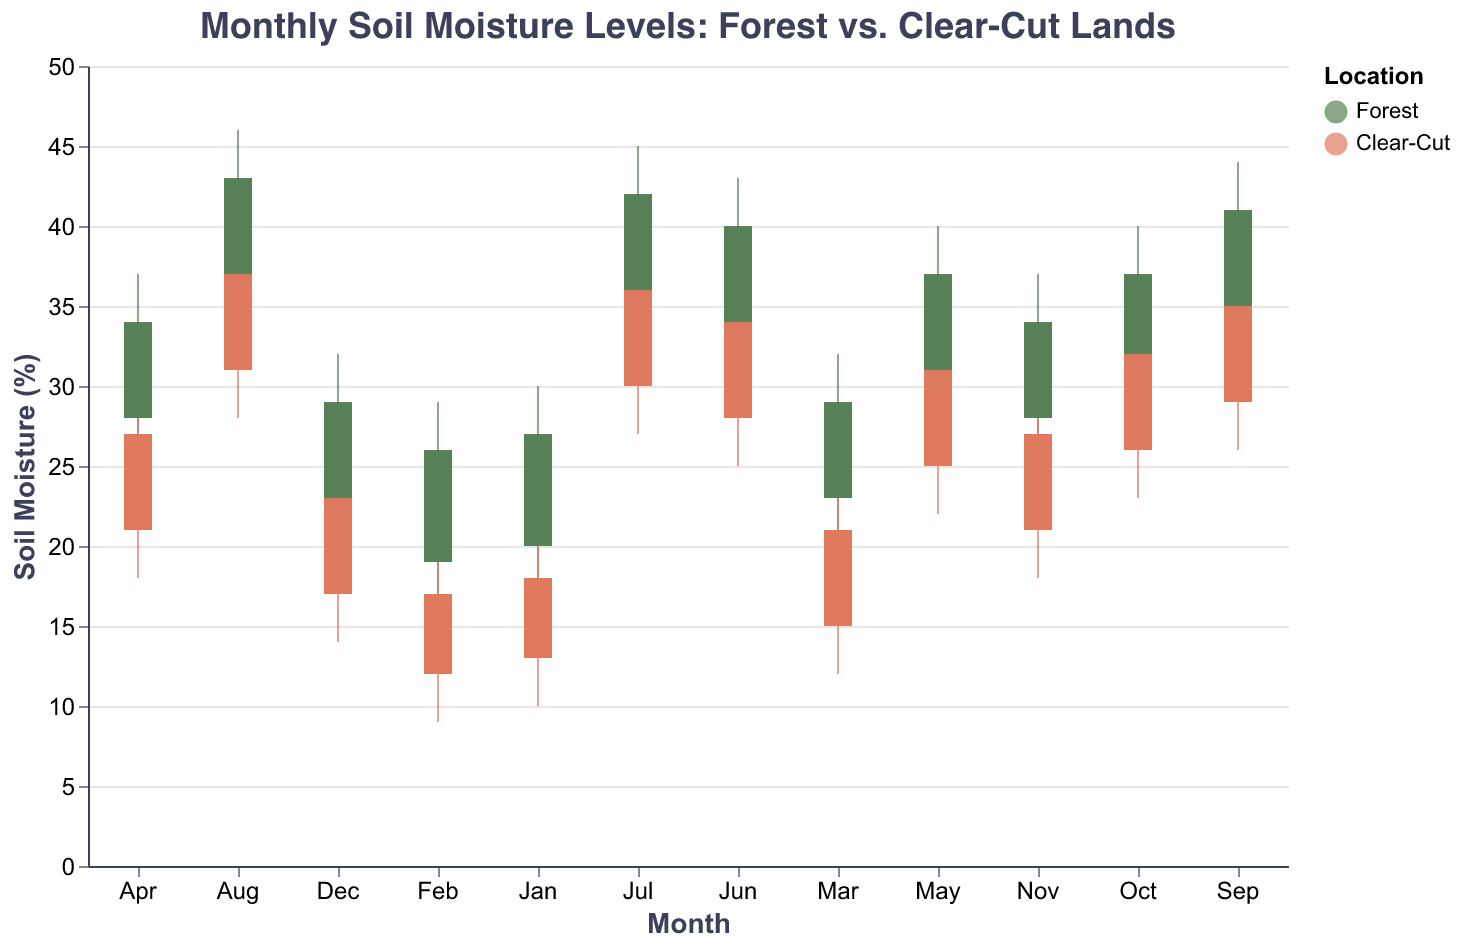What is the range of soil moisture in forests during July? The range of soil moisture can be calculated by subtracting the minimum value from the maximum value. In July, the minimum soil moisture in forests is 32%, and the maximum is 45%. So, the range is 45% - 32% = 13%.
Answer: 13% How does the median soil moisture in forests compare to clear-cut lands in May? The median soil moisture in forests in May is 34%, and in clear-cut lands, it is 28%. Comparing these values, the median soil moisture in forests is higher than in clear-cut lands.
Answer: Higher What is the quartile range of soil moisture in clear-cut lands during March? The quartile range can be found by subtracting the first quartile (Q1) from the third quartile (Q3). In March, Q1 for clear-cut lands is 15% and Q3 is 21%. So, the quartile range is 21% - 15% = 6%.
Answer: 6% Which month shows the highest median soil moisture for forests? We can scan through the median values for forests across all months. July has the highest median soil moisture at 38%.
Answer: July Is there a month where clear-cut lands have a higher maximum soil moisture level than forests? To answer, compare the maximum soil moisture levels for each month. There is no month where the clear-cut lands' maximum soil moisture exceeds forests'.
Answer: No What is the difference in the median soil moisture between forests and clear-cut lands in December? The median soil moisture in forests for December is 26%, and for clear-cut lands, it is 20%. The difference is 26% - 20% = 6%.
Answer: 6% During which month do both forests and clear-cut lands share the same range of soil moisture? We check the range (Max - Min) for both locations across all months. Both have the same range in June: 43% - 30% (forest) and 37% - 25% (clear-cut), both equal 13%.
Answer: June What is the median soil moisture level in clear-cut lands during September? The median value for clear-cut lands in September can be directly read from the figure, which is 32%.
Answer: 32% In which month is the minimum soil moisture level higher in clear-cut lands than in forests? By comparing the minimum soil moisture levels across all months, there is no month where the clear-cut lands have a higher minimum value than forests.
Answer: No month 